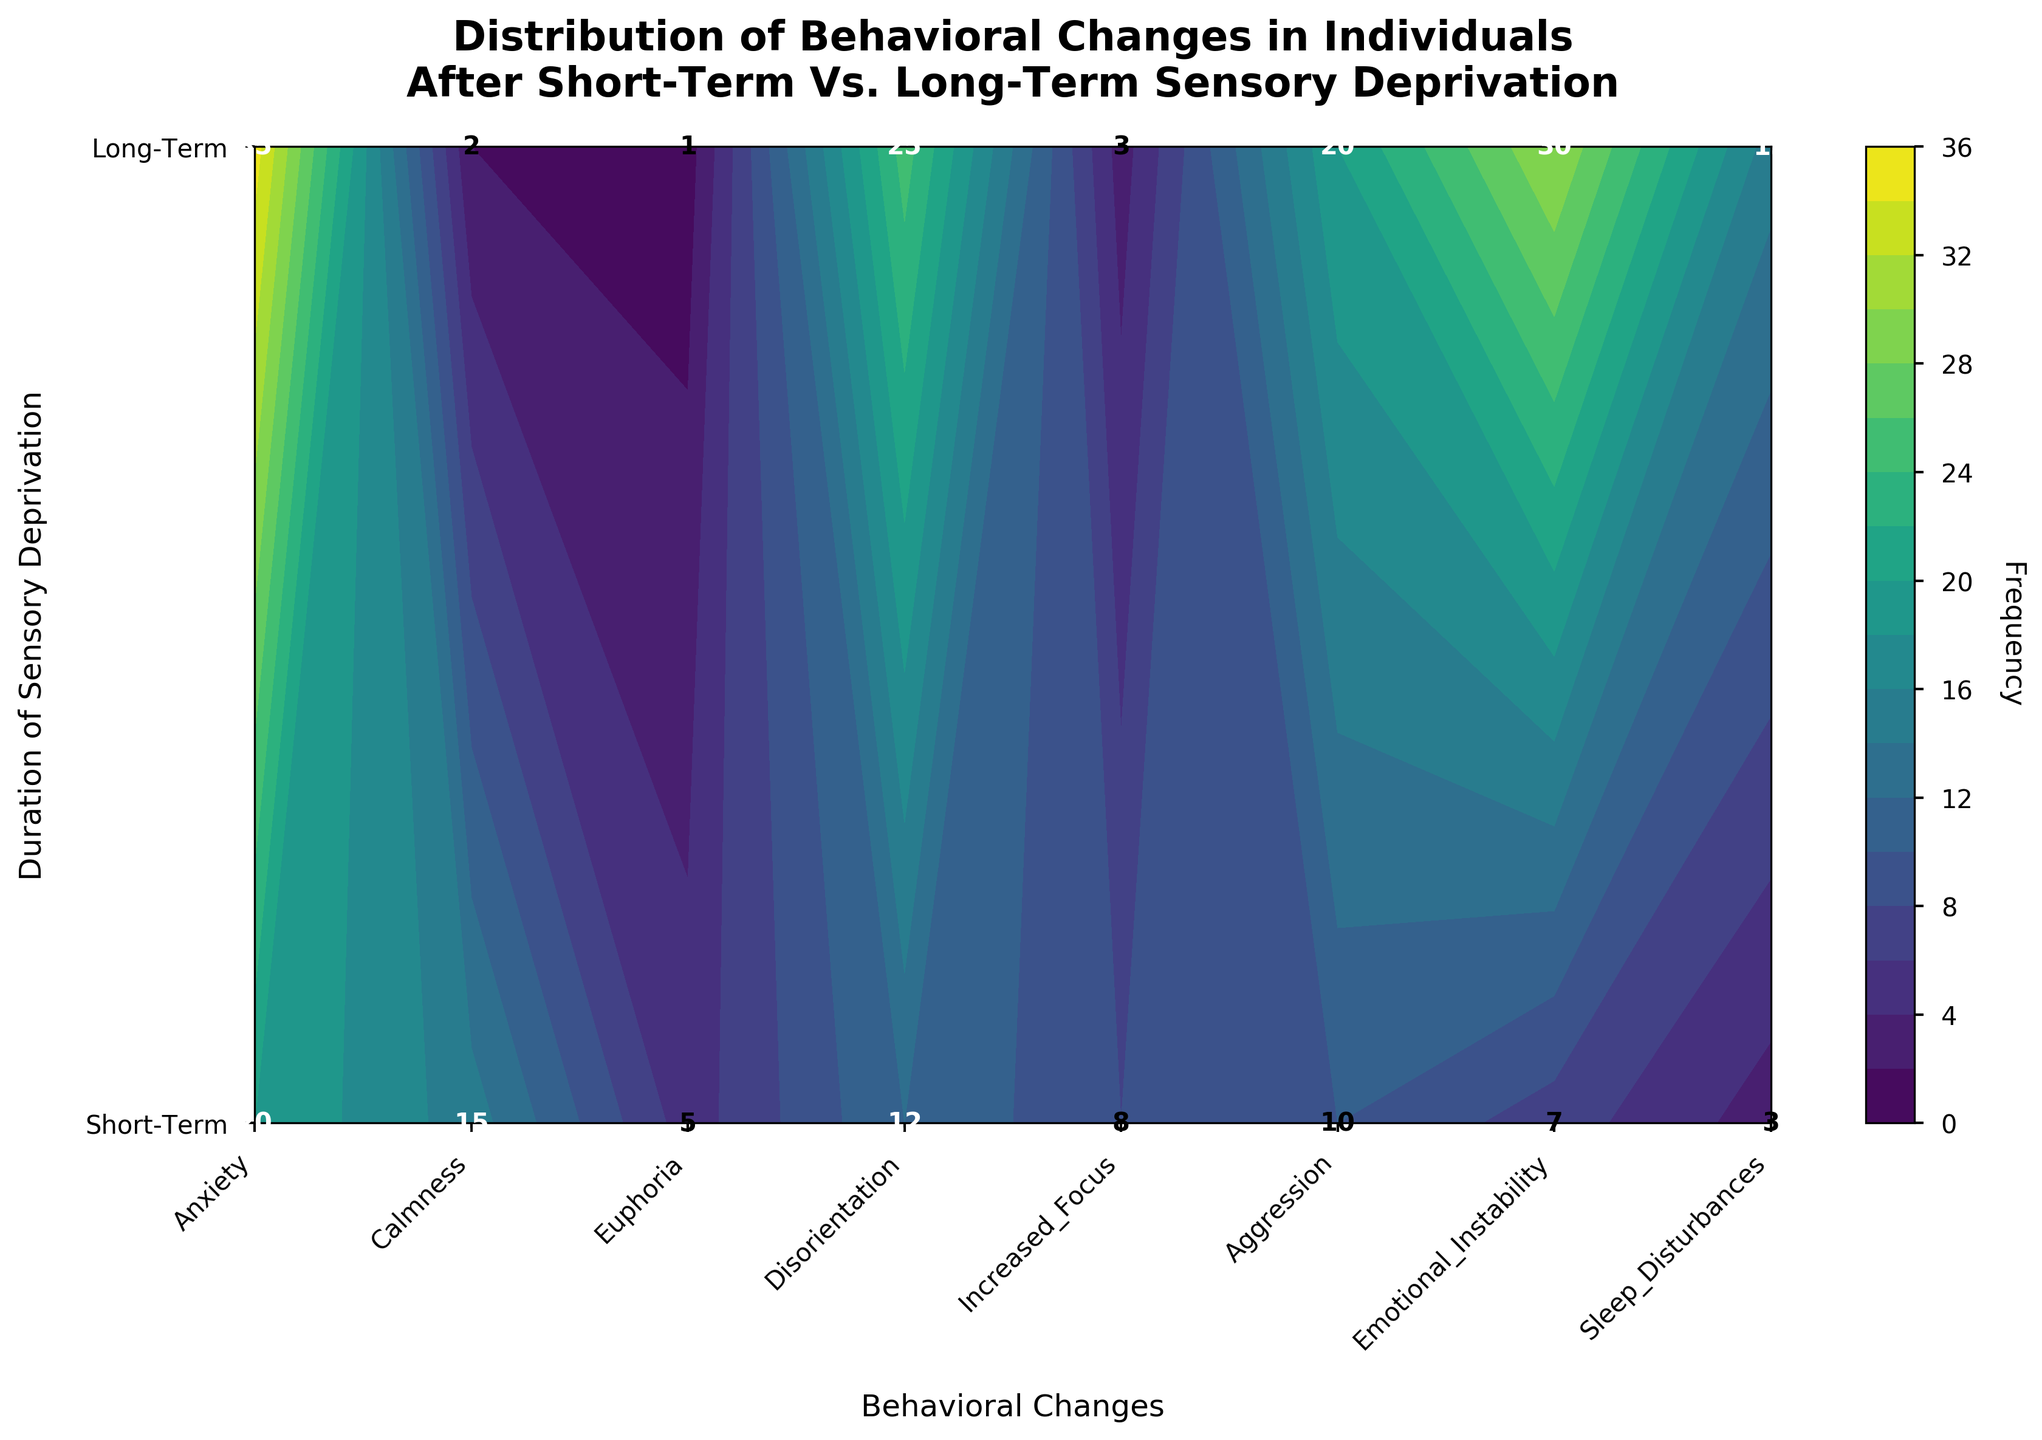What is the title of the figure? The title of the figure is presented at the top and typically summarizes the content of the plot. In this case, it reads "Distribution of Behavioral Changes in Individuals After Short-Term Vs. Long-Term Sensory Deprivation".
Answer: Distribution of Behavioral Changes in Individuals After Short-Term Vs. Long-Term Sensory Deprivation What does the y-axis label indicate? The y-axis label indicates the duration of sensory deprivation. This is shown on the left of the plot as "Duration of Sensory Deprivation". The two possible durations are "Short-Term" and "Long-Term".
Answer: Duration of Sensory Deprivation Which behavioral change has the highest frequency after long-term sensory deprivation? To find this, look at the contour labeled "Long-Term" and identify the peak value. This behavioral change is Anxiety with a frequency of 35.
Answer: Anxiety Which behavioral change has the lowest frequency after short-term sensory deprivation? Examine the frequencies associated with each behavioral change under the "Short-Term" category. The behavioral change with the lowest frequency is Sleep Disturbances, with a frequency of 3.
Answer: Sleep Disturbances How many behavioral changes have a frequency greater than 10 after long-term sensory deprivation? Count the behavioral changes with frequencies above 10 under the "Long-Term" category. These behavioral changes are Anxiety (35), Disorientation (25), Aggression (20), Emotional Instability (30), and Sleep Disturbances (15), totalling five.
Answer: 5 What is the average frequency of behavioral changes in the short-term category? To find the average frequency, sum all the frequencies in the short-term category and divide by the number of behavioral changes. The total frequency is 20 + 15 + 5 + 12 + 8 + 10 + 7 + 3 = 80, and there are 8 behavioral changes, so the average is 80/8 = 10.
Answer: 10 Which behavioral change shows the greatest difference in frequency between short-term and long-term sensory deprivation? Calculate differences for each behavioral change. The differences are: Anxiety (35 - 20 = 15), Calmness (2 - 15 = -13), Euphoria (1 - 5 = -4), Disorientation (25 - 12 = 13), Increased Focus (3 - 8 = -5), Aggression (20 - 10 = 10), Emotional Instability (30 - 7 = 23), Sleep Disturbances (15 - 3 = 12). The greatest difference is for Emotional Instability (23).
Answer: Emotional Instability What is the cumulative frequency of emotional instability across both short-term and long-term sensory deprivation? Add the frequencies of emotional instability for both short-term and long-term duration. The frequencies are 7 (Short-Term) and 30 (Long-Term). The cumulative frequency is 7 + 30 = 37.
Answer: 37 Which behavioral change has a similar frequency between short-term and long-term sensory deprivation? Compare frequencies across all behavioral changes for both durations. Increased Focus shows similar frequencies: 8 (Short-Term) and 3 (Long-Term). The difference is minimal compared to other behavioral changes.
Answer: Increased Focus 